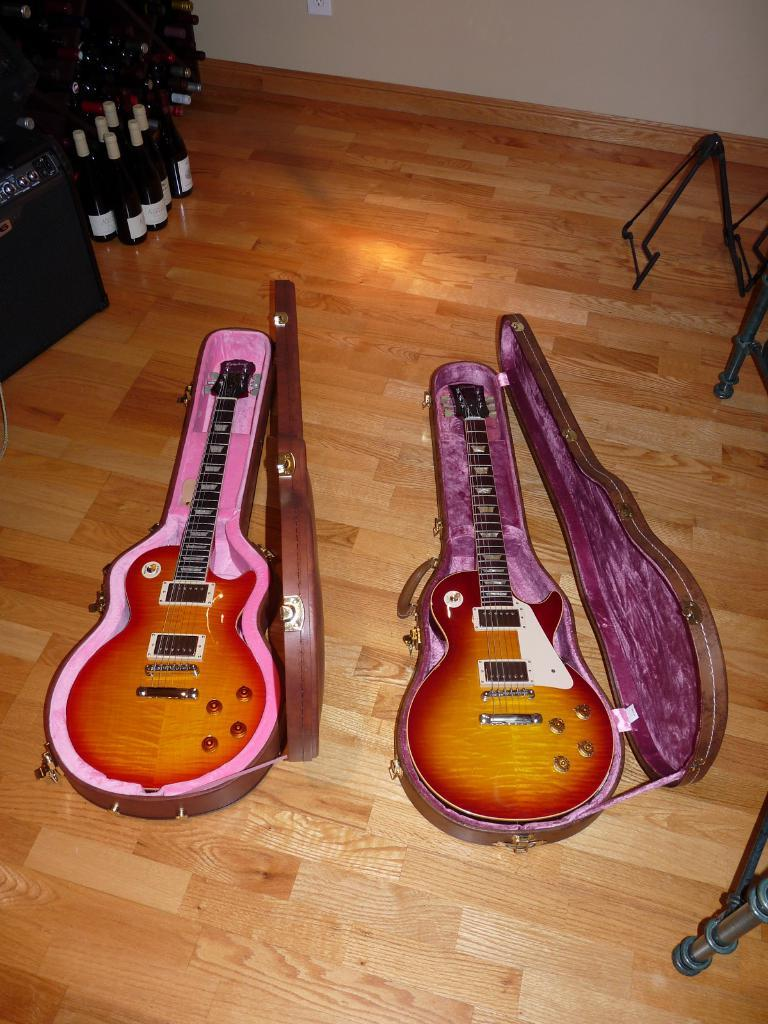What can be seen in the background of the image? There is a wall and a socket in the background of the image. What objects are on the floor in the image? There are guitars and bottles on the floor in the image. Reasoning: Let's think step by identifying the main subjects and objects in the image based on the provided facts. We then formulate questions that focus on the location and characteristics of these subjects and objects, ensuring that each question can be answered definitively with the information given. We avoid yes/no questions and ensure that the language is simple and clear. Absurd Question/Answer: What type of horn is being played in the image? There is no horn present in the image; it features guitars on the floor. What does the caption say in the image? There is no caption present in the image. What type of bean is being used as a musical instrument in the image? There is no bean present in the image, and beans are not used as musical instruments. 